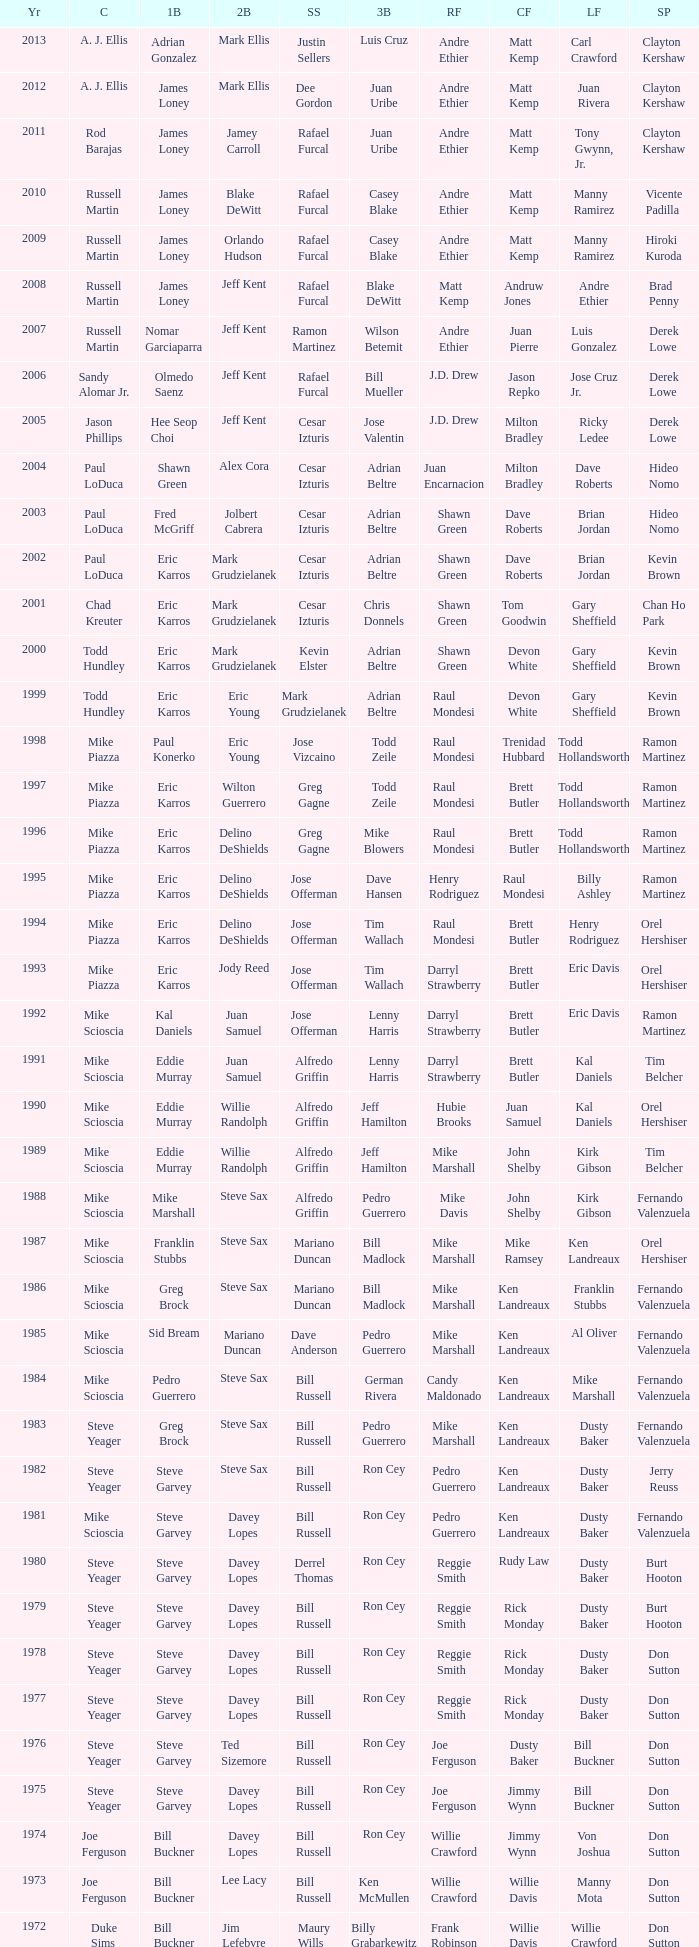Who was the SS when jim lefebvre was at 2nd, willie davis at CF, and don drysdale was the SP. Maury Wills. 